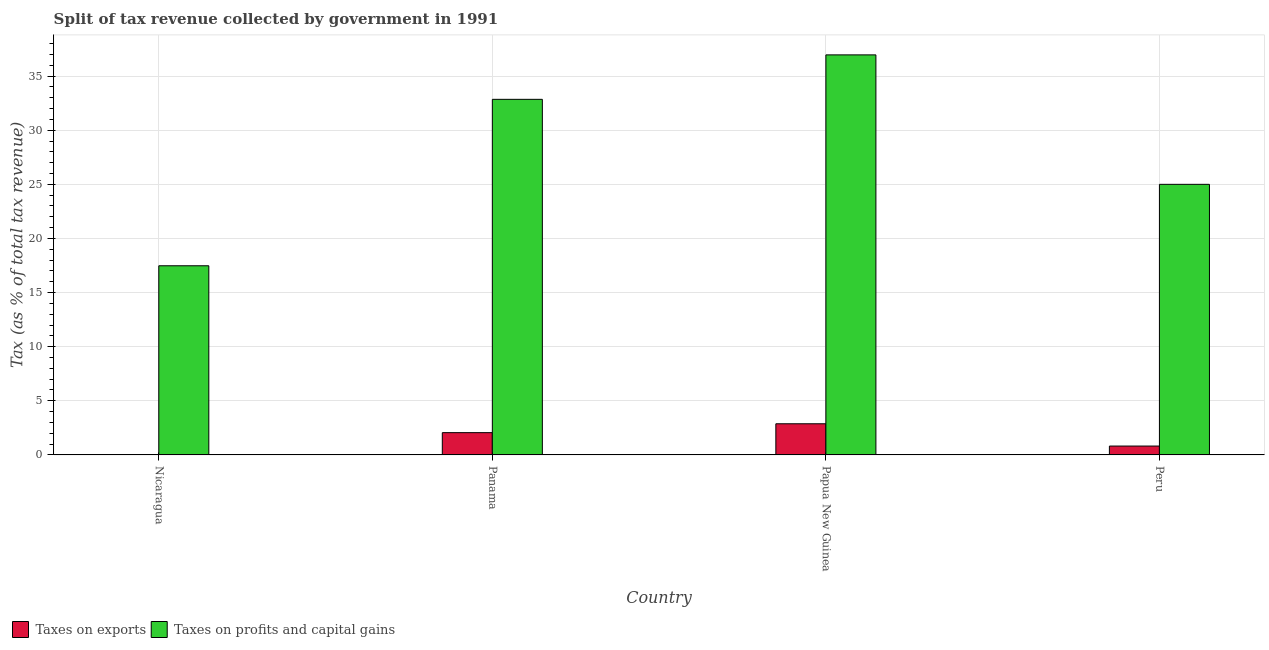Are the number of bars per tick equal to the number of legend labels?
Provide a short and direct response. Yes. How many bars are there on the 3rd tick from the left?
Make the answer very short. 2. How many bars are there on the 3rd tick from the right?
Offer a very short reply. 2. In how many cases, is the number of bars for a given country not equal to the number of legend labels?
Provide a short and direct response. 0. What is the percentage of revenue obtained from taxes on exports in Peru?
Ensure brevity in your answer.  0.82. Across all countries, what is the maximum percentage of revenue obtained from taxes on exports?
Provide a short and direct response. 2.88. Across all countries, what is the minimum percentage of revenue obtained from taxes on exports?
Provide a short and direct response. 0.03. In which country was the percentage of revenue obtained from taxes on exports maximum?
Give a very brief answer. Papua New Guinea. In which country was the percentage of revenue obtained from taxes on profits and capital gains minimum?
Your answer should be compact. Nicaragua. What is the total percentage of revenue obtained from taxes on profits and capital gains in the graph?
Provide a short and direct response. 112.29. What is the difference between the percentage of revenue obtained from taxes on exports in Nicaragua and that in Peru?
Your answer should be compact. -0.79. What is the difference between the percentage of revenue obtained from taxes on exports in Papua New Guinea and the percentage of revenue obtained from taxes on profits and capital gains in Nicaragua?
Provide a succinct answer. -14.6. What is the average percentage of revenue obtained from taxes on profits and capital gains per country?
Provide a succinct answer. 28.07. What is the difference between the percentage of revenue obtained from taxes on profits and capital gains and percentage of revenue obtained from taxes on exports in Nicaragua?
Ensure brevity in your answer.  17.45. In how many countries, is the percentage of revenue obtained from taxes on exports greater than 31 %?
Your response must be concise. 0. What is the ratio of the percentage of revenue obtained from taxes on exports in Papua New Guinea to that in Peru?
Provide a succinct answer. 3.51. What is the difference between the highest and the second highest percentage of revenue obtained from taxes on profits and capital gains?
Your answer should be compact. 4.11. What is the difference between the highest and the lowest percentage of revenue obtained from taxes on exports?
Keep it short and to the point. 2.85. In how many countries, is the percentage of revenue obtained from taxes on exports greater than the average percentage of revenue obtained from taxes on exports taken over all countries?
Your answer should be compact. 2. What does the 1st bar from the left in Nicaragua represents?
Offer a terse response. Taxes on exports. What does the 1st bar from the right in Papua New Guinea represents?
Provide a short and direct response. Taxes on profits and capital gains. How many bars are there?
Provide a short and direct response. 8. How many countries are there in the graph?
Give a very brief answer. 4. Are the values on the major ticks of Y-axis written in scientific E-notation?
Offer a very short reply. No. How are the legend labels stacked?
Your response must be concise. Horizontal. What is the title of the graph?
Your answer should be compact. Split of tax revenue collected by government in 1991. Does "Urban Population" appear as one of the legend labels in the graph?
Keep it short and to the point. No. What is the label or title of the Y-axis?
Keep it short and to the point. Tax (as % of total tax revenue). What is the Tax (as % of total tax revenue) of Taxes on exports in Nicaragua?
Ensure brevity in your answer.  0.03. What is the Tax (as % of total tax revenue) in Taxes on profits and capital gains in Nicaragua?
Provide a succinct answer. 17.48. What is the Tax (as % of total tax revenue) of Taxes on exports in Panama?
Provide a short and direct response. 2.06. What is the Tax (as % of total tax revenue) of Taxes on profits and capital gains in Panama?
Your response must be concise. 32.85. What is the Tax (as % of total tax revenue) of Taxes on exports in Papua New Guinea?
Keep it short and to the point. 2.88. What is the Tax (as % of total tax revenue) in Taxes on profits and capital gains in Papua New Guinea?
Offer a very short reply. 36.96. What is the Tax (as % of total tax revenue) of Taxes on exports in Peru?
Your answer should be very brief. 0.82. What is the Tax (as % of total tax revenue) in Taxes on profits and capital gains in Peru?
Your response must be concise. 25. Across all countries, what is the maximum Tax (as % of total tax revenue) in Taxes on exports?
Your response must be concise. 2.88. Across all countries, what is the maximum Tax (as % of total tax revenue) in Taxes on profits and capital gains?
Give a very brief answer. 36.96. Across all countries, what is the minimum Tax (as % of total tax revenue) in Taxes on exports?
Your answer should be compact. 0.03. Across all countries, what is the minimum Tax (as % of total tax revenue) of Taxes on profits and capital gains?
Ensure brevity in your answer.  17.48. What is the total Tax (as % of total tax revenue) in Taxes on exports in the graph?
Ensure brevity in your answer.  5.79. What is the total Tax (as % of total tax revenue) in Taxes on profits and capital gains in the graph?
Offer a very short reply. 112.29. What is the difference between the Tax (as % of total tax revenue) in Taxes on exports in Nicaragua and that in Panama?
Your answer should be very brief. -2.03. What is the difference between the Tax (as % of total tax revenue) in Taxes on profits and capital gains in Nicaragua and that in Panama?
Provide a short and direct response. -15.38. What is the difference between the Tax (as % of total tax revenue) of Taxes on exports in Nicaragua and that in Papua New Guinea?
Provide a succinct answer. -2.85. What is the difference between the Tax (as % of total tax revenue) in Taxes on profits and capital gains in Nicaragua and that in Papua New Guinea?
Provide a short and direct response. -19.48. What is the difference between the Tax (as % of total tax revenue) of Taxes on exports in Nicaragua and that in Peru?
Provide a succinct answer. -0.79. What is the difference between the Tax (as % of total tax revenue) of Taxes on profits and capital gains in Nicaragua and that in Peru?
Your response must be concise. -7.52. What is the difference between the Tax (as % of total tax revenue) in Taxes on exports in Panama and that in Papua New Guinea?
Provide a succinct answer. -0.82. What is the difference between the Tax (as % of total tax revenue) in Taxes on profits and capital gains in Panama and that in Papua New Guinea?
Offer a terse response. -4.11. What is the difference between the Tax (as % of total tax revenue) of Taxes on exports in Panama and that in Peru?
Provide a succinct answer. 1.24. What is the difference between the Tax (as % of total tax revenue) in Taxes on profits and capital gains in Panama and that in Peru?
Keep it short and to the point. 7.85. What is the difference between the Tax (as % of total tax revenue) of Taxes on exports in Papua New Guinea and that in Peru?
Keep it short and to the point. 2.06. What is the difference between the Tax (as % of total tax revenue) of Taxes on profits and capital gains in Papua New Guinea and that in Peru?
Make the answer very short. 11.96. What is the difference between the Tax (as % of total tax revenue) of Taxes on exports in Nicaragua and the Tax (as % of total tax revenue) of Taxes on profits and capital gains in Panama?
Give a very brief answer. -32.83. What is the difference between the Tax (as % of total tax revenue) of Taxes on exports in Nicaragua and the Tax (as % of total tax revenue) of Taxes on profits and capital gains in Papua New Guinea?
Provide a short and direct response. -36.93. What is the difference between the Tax (as % of total tax revenue) of Taxes on exports in Nicaragua and the Tax (as % of total tax revenue) of Taxes on profits and capital gains in Peru?
Your response must be concise. -24.97. What is the difference between the Tax (as % of total tax revenue) of Taxes on exports in Panama and the Tax (as % of total tax revenue) of Taxes on profits and capital gains in Papua New Guinea?
Your response must be concise. -34.9. What is the difference between the Tax (as % of total tax revenue) of Taxes on exports in Panama and the Tax (as % of total tax revenue) of Taxes on profits and capital gains in Peru?
Provide a succinct answer. -22.94. What is the difference between the Tax (as % of total tax revenue) of Taxes on exports in Papua New Guinea and the Tax (as % of total tax revenue) of Taxes on profits and capital gains in Peru?
Make the answer very short. -22.12. What is the average Tax (as % of total tax revenue) of Taxes on exports per country?
Provide a succinct answer. 1.45. What is the average Tax (as % of total tax revenue) of Taxes on profits and capital gains per country?
Offer a terse response. 28.07. What is the difference between the Tax (as % of total tax revenue) of Taxes on exports and Tax (as % of total tax revenue) of Taxes on profits and capital gains in Nicaragua?
Give a very brief answer. -17.45. What is the difference between the Tax (as % of total tax revenue) of Taxes on exports and Tax (as % of total tax revenue) of Taxes on profits and capital gains in Panama?
Give a very brief answer. -30.79. What is the difference between the Tax (as % of total tax revenue) of Taxes on exports and Tax (as % of total tax revenue) of Taxes on profits and capital gains in Papua New Guinea?
Your response must be concise. -34.08. What is the difference between the Tax (as % of total tax revenue) in Taxes on exports and Tax (as % of total tax revenue) in Taxes on profits and capital gains in Peru?
Your response must be concise. -24.18. What is the ratio of the Tax (as % of total tax revenue) in Taxes on exports in Nicaragua to that in Panama?
Give a very brief answer. 0.01. What is the ratio of the Tax (as % of total tax revenue) in Taxes on profits and capital gains in Nicaragua to that in Panama?
Provide a short and direct response. 0.53. What is the ratio of the Tax (as % of total tax revenue) in Taxes on exports in Nicaragua to that in Papua New Guinea?
Give a very brief answer. 0.01. What is the ratio of the Tax (as % of total tax revenue) in Taxes on profits and capital gains in Nicaragua to that in Papua New Guinea?
Your response must be concise. 0.47. What is the ratio of the Tax (as % of total tax revenue) of Taxes on exports in Nicaragua to that in Peru?
Keep it short and to the point. 0.03. What is the ratio of the Tax (as % of total tax revenue) of Taxes on profits and capital gains in Nicaragua to that in Peru?
Your answer should be very brief. 0.7. What is the ratio of the Tax (as % of total tax revenue) of Taxes on exports in Panama to that in Papua New Guinea?
Keep it short and to the point. 0.72. What is the ratio of the Tax (as % of total tax revenue) of Taxes on profits and capital gains in Panama to that in Papua New Guinea?
Provide a short and direct response. 0.89. What is the ratio of the Tax (as % of total tax revenue) in Taxes on exports in Panama to that in Peru?
Provide a short and direct response. 2.51. What is the ratio of the Tax (as % of total tax revenue) in Taxes on profits and capital gains in Panama to that in Peru?
Offer a very short reply. 1.31. What is the ratio of the Tax (as % of total tax revenue) in Taxes on exports in Papua New Guinea to that in Peru?
Provide a succinct answer. 3.51. What is the ratio of the Tax (as % of total tax revenue) of Taxes on profits and capital gains in Papua New Guinea to that in Peru?
Your answer should be very brief. 1.48. What is the difference between the highest and the second highest Tax (as % of total tax revenue) of Taxes on exports?
Provide a succinct answer. 0.82. What is the difference between the highest and the second highest Tax (as % of total tax revenue) of Taxes on profits and capital gains?
Keep it short and to the point. 4.11. What is the difference between the highest and the lowest Tax (as % of total tax revenue) of Taxes on exports?
Provide a succinct answer. 2.85. What is the difference between the highest and the lowest Tax (as % of total tax revenue) of Taxes on profits and capital gains?
Provide a short and direct response. 19.48. 